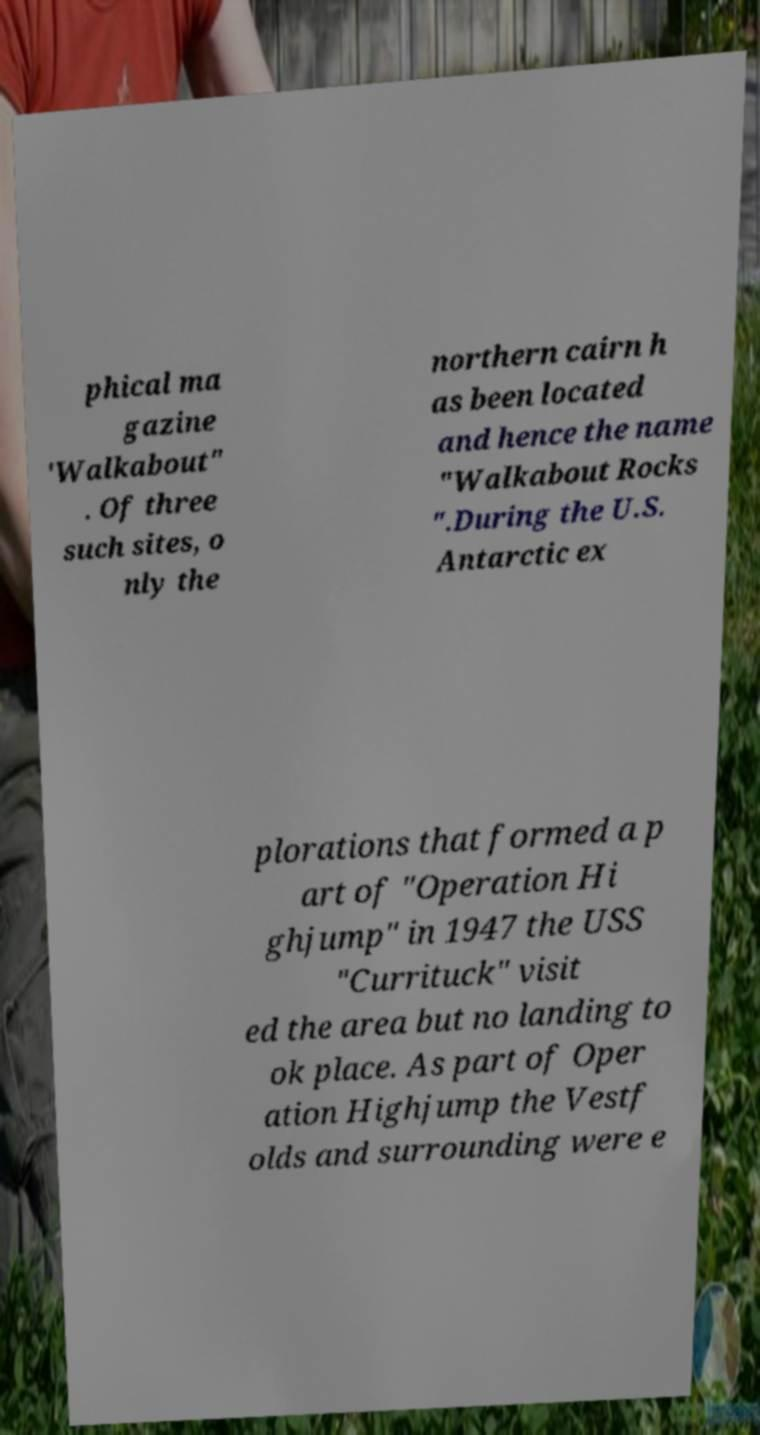What messages or text are displayed in this image? I need them in a readable, typed format. phical ma gazine 'Walkabout" . Of three such sites, o nly the northern cairn h as been located and hence the name "Walkabout Rocks ".During the U.S. Antarctic ex plorations that formed a p art of "Operation Hi ghjump" in 1947 the USS "Currituck" visit ed the area but no landing to ok place. As part of Oper ation Highjump the Vestf olds and surrounding were e 